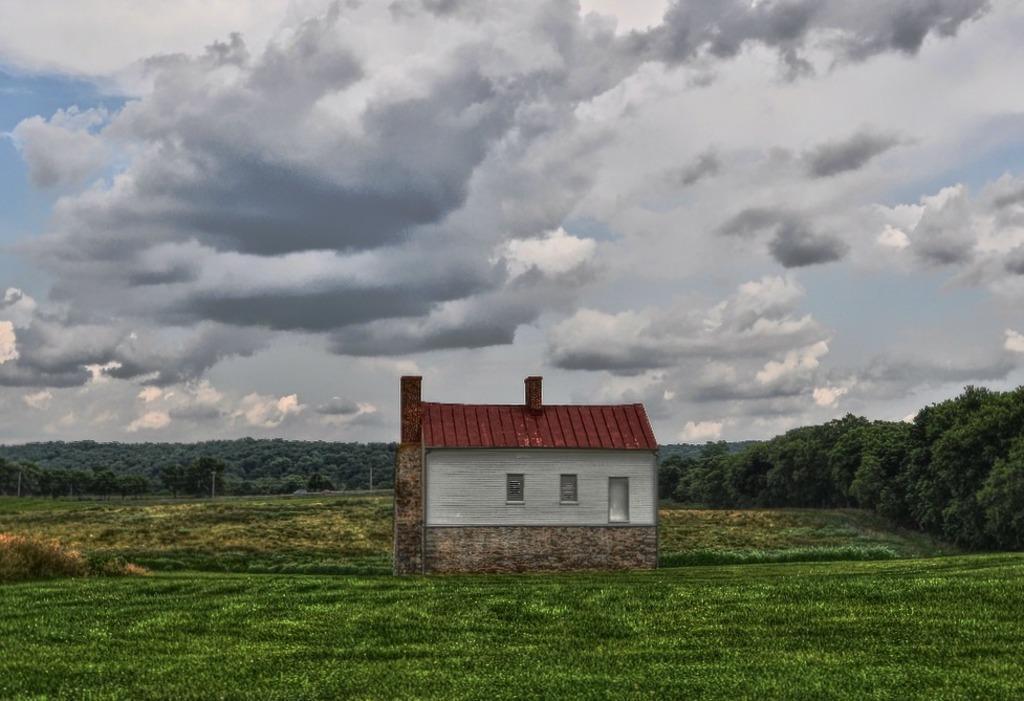Could you give a brief overview of what you see in this image? In this image I can see the house and the grass. In the background I can see many trees, clouds and the sky. 